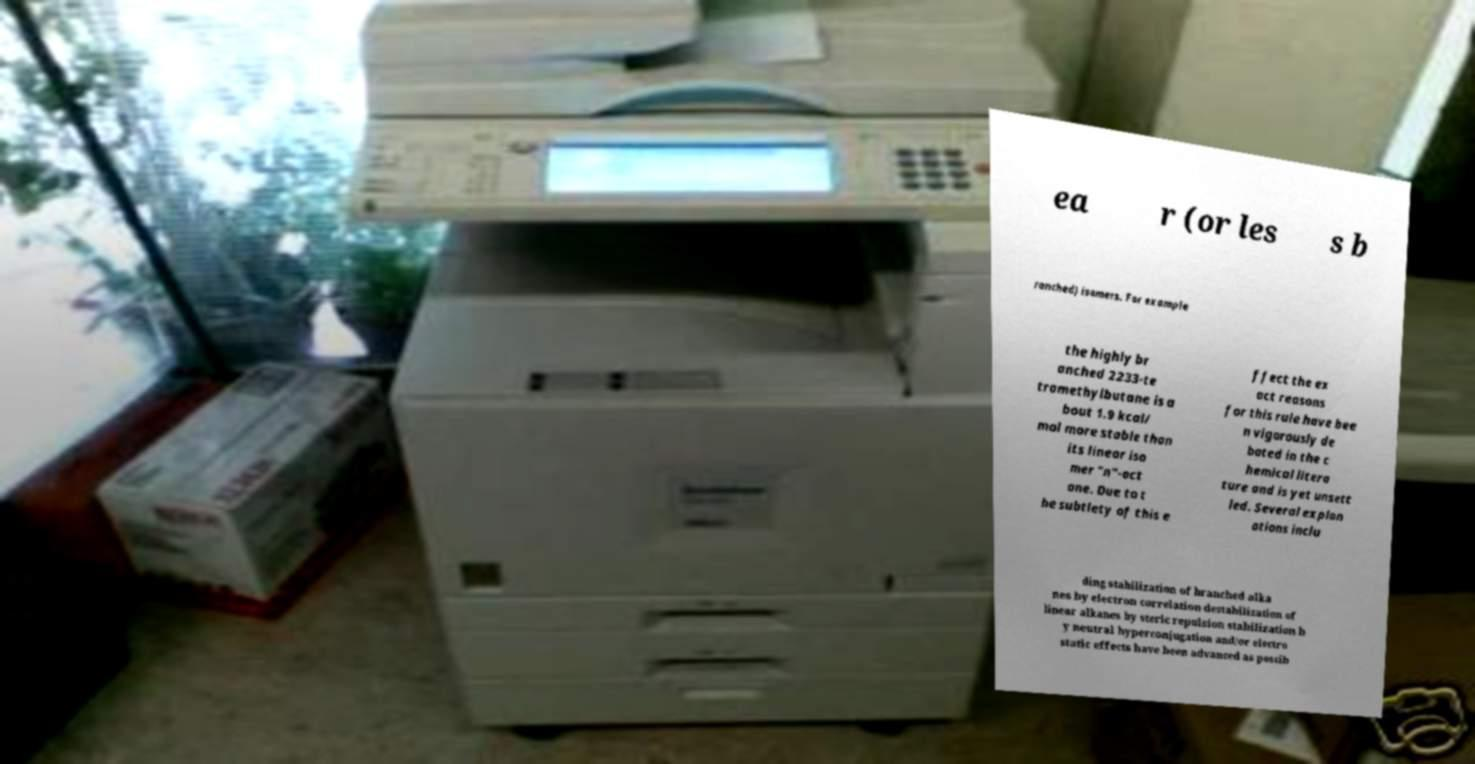Can you read and provide the text displayed in the image?This photo seems to have some interesting text. Can you extract and type it out for me? ea r (or les s b ranched) isomers. For example the highly br anched 2233-te tramethylbutane is a bout 1.9 kcal/ mol more stable than its linear iso mer "n"-oct ane. Due to t he subtlety of this e ffect the ex act reasons for this rule have bee n vigorously de bated in the c hemical litera ture and is yet unsett led. Several explan ations inclu ding stabilization of branched alka nes by electron correlation destabilization of linear alkanes by steric repulsion stabilization b y neutral hyperconjugation and/or electro static effects have been advanced as possib 